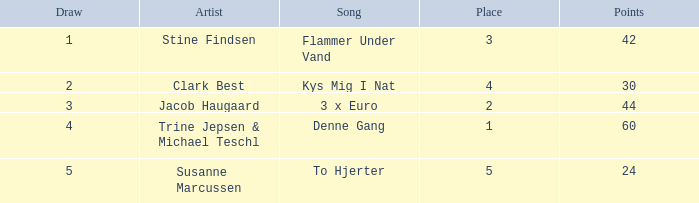What is the mean draw when the location is greater than 5? None. 